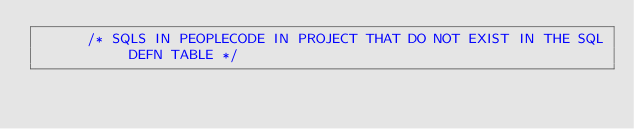<code> <loc_0><loc_0><loc_500><loc_500><_SQL_>      /* SQLS IN PEOPLECODE IN PROJECT THAT DO NOT EXIST IN THE SQL DEFN TABLE */</code> 